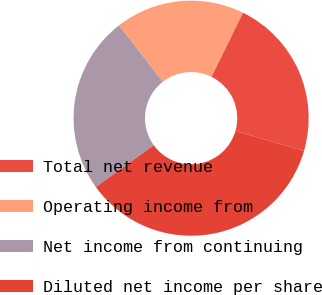Convert chart. <chart><loc_0><loc_0><loc_500><loc_500><pie_chart><fcel>Total net revenue<fcel>Operating income from<fcel>Net income from continuing<fcel>Diluted net income per share<nl><fcel>22.22%<fcel>17.78%<fcel>24.44%<fcel>35.56%<nl></chart> 